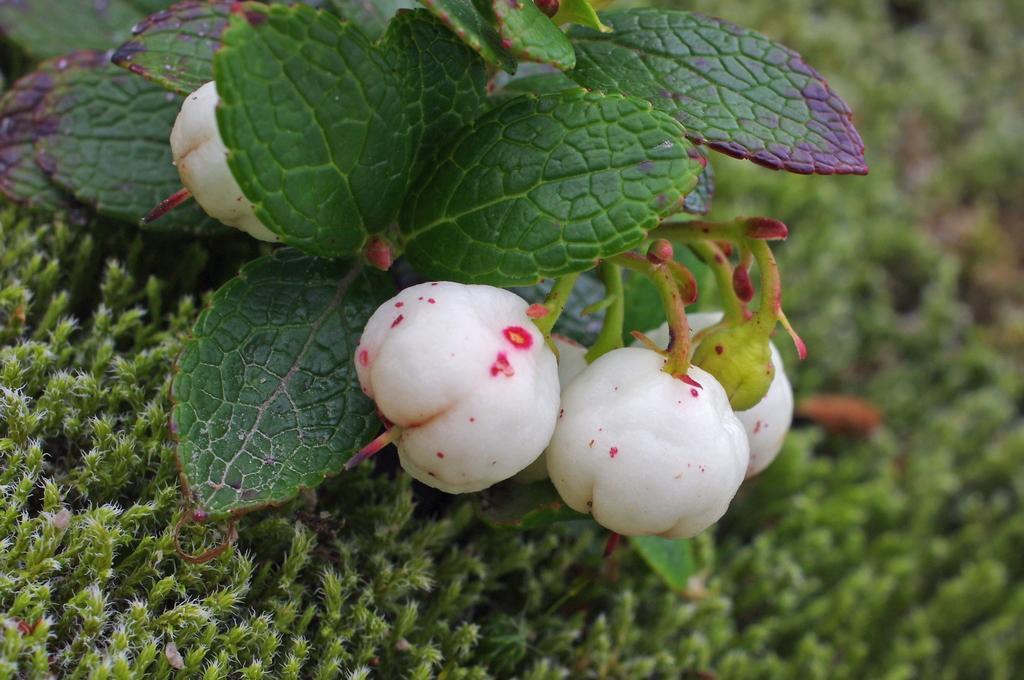Please provide a concise description of this image. In this picture I can see there are Bilberries and there have few leaves and there are few small plants on the floor. 